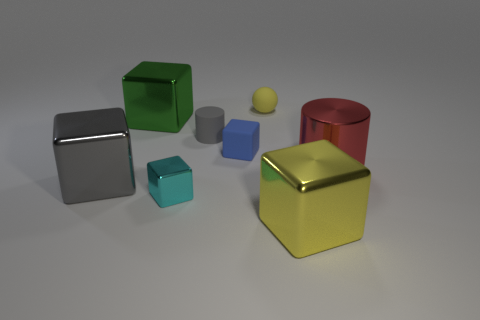Subtract all tiny blocks. How many blocks are left? 3 Subtract all green blocks. How many blocks are left? 4 Add 1 large things. How many objects exist? 9 Subtract 0 green balls. How many objects are left? 8 Subtract all cylinders. How many objects are left? 6 Subtract all purple spheres. Subtract all red cylinders. How many spheres are left? 1 Subtract all big metal objects. Subtract all small cyan things. How many objects are left? 3 Add 6 cyan metal cubes. How many cyan metal cubes are left? 7 Add 2 cyan blocks. How many cyan blocks exist? 3 